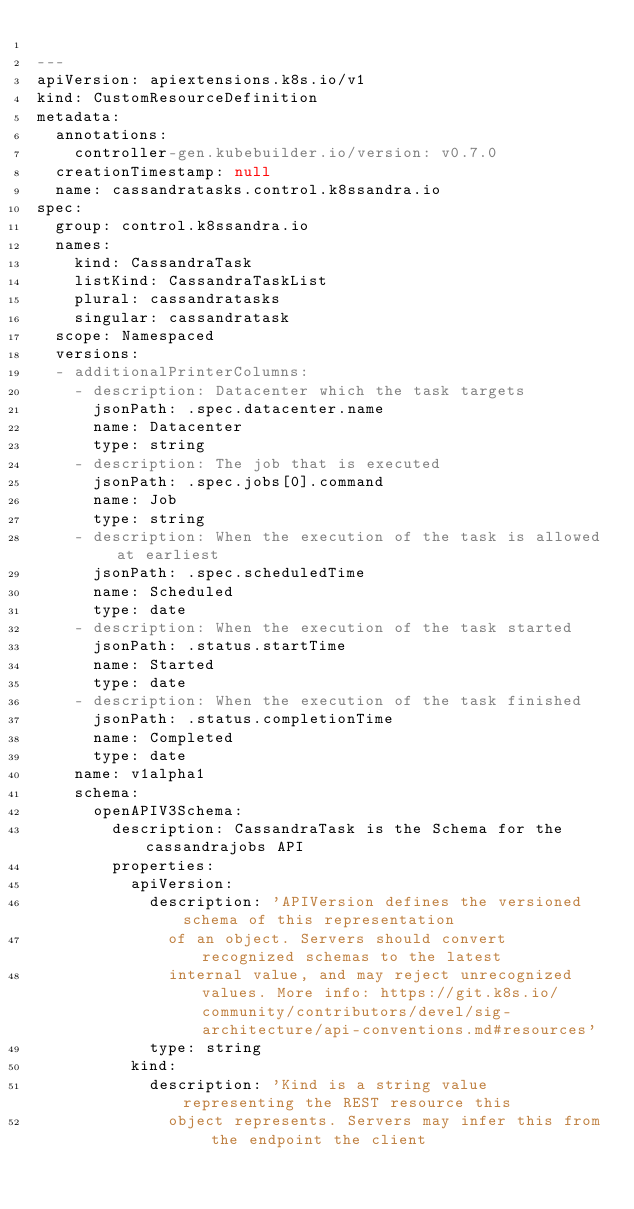<code> <loc_0><loc_0><loc_500><loc_500><_YAML_>
---
apiVersion: apiextensions.k8s.io/v1
kind: CustomResourceDefinition
metadata:
  annotations:
    controller-gen.kubebuilder.io/version: v0.7.0
  creationTimestamp: null
  name: cassandratasks.control.k8ssandra.io
spec:
  group: control.k8ssandra.io
  names:
    kind: CassandraTask
    listKind: CassandraTaskList
    plural: cassandratasks
    singular: cassandratask
  scope: Namespaced
  versions:
  - additionalPrinterColumns:
    - description: Datacenter which the task targets
      jsonPath: .spec.datacenter.name
      name: Datacenter
      type: string
    - description: The job that is executed
      jsonPath: .spec.jobs[0].command
      name: Job
      type: string
    - description: When the execution of the task is allowed at earliest
      jsonPath: .spec.scheduledTime
      name: Scheduled
      type: date
    - description: When the execution of the task started
      jsonPath: .status.startTime
      name: Started
      type: date
    - description: When the execution of the task finished
      jsonPath: .status.completionTime
      name: Completed
      type: date
    name: v1alpha1
    schema:
      openAPIV3Schema:
        description: CassandraTask is the Schema for the cassandrajobs API
        properties:
          apiVersion:
            description: 'APIVersion defines the versioned schema of this representation
              of an object. Servers should convert recognized schemas to the latest
              internal value, and may reject unrecognized values. More info: https://git.k8s.io/community/contributors/devel/sig-architecture/api-conventions.md#resources'
            type: string
          kind:
            description: 'Kind is a string value representing the REST resource this
              object represents. Servers may infer this from the endpoint the client</code> 